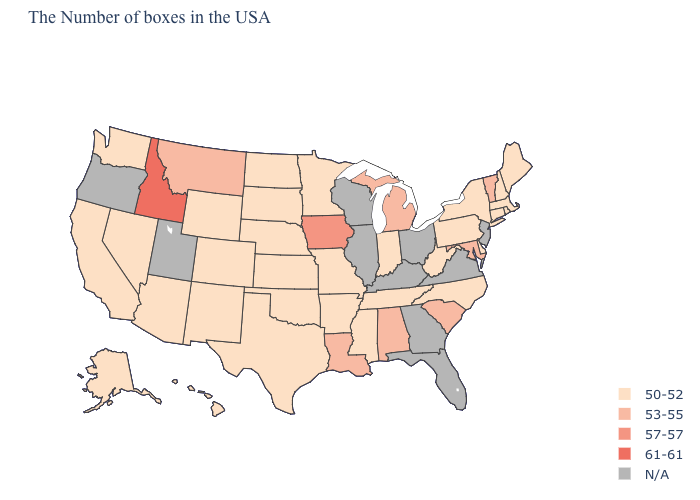What is the lowest value in the Northeast?
Short answer required. 50-52. What is the value of Nebraska?
Give a very brief answer. 50-52. What is the value of Colorado?
Be succinct. 50-52. What is the lowest value in the USA?
Concise answer only. 50-52. What is the highest value in the West ?
Quick response, please. 61-61. What is the value of Idaho?
Concise answer only. 61-61. Which states have the lowest value in the USA?
Be succinct. Maine, Massachusetts, Rhode Island, New Hampshire, Connecticut, New York, Delaware, Pennsylvania, North Carolina, West Virginia, Indiana, Tennessee, Mississippi, Missouri, Arkansas, Minnesota, Kansas, Nebraska, Oklahoma, Texas, South Dakota, North Dakota, Wyoming, Colorado, New Mexico, Arizona, Nevada, California, Washington, Alaska, Hawaii. What is the highest value in the USA?
Short answer required. 61-61. Among the states that border Wisconsin , which have the highest value?
Write a very short answer. Iowa. What is the value of Delaware?
Be succinct. 50-52. Name the states that have a value in the range 50-52?
Keep it brief. Maine, Massachusetts, Rhode Island, New Hampshire, Connecticut, New York, Delaware, Pennsylvania, North Carolina, West Virginia, Indiana, Tennessee, Mississippi, Missouri, Arkansas, Minnesota, Kansas, Nebraska, Oklahoma, Texas, South Dakota, North Dakota, Wyoming, Colorado, New Mexico, Arizona, Nevada, California, Washington, Alaska, Hawaii. Name the states that have a value in the range 57-57?
Short answer required. Iowa. What is the highest value in states that border South Carolina?
Keep it brief. 50-52. Does the map have missing data?
Quick response, please. Yes. 